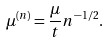Convert formula to latex. <formula><loc_0><loc_0><loc_500><loc_500>\mu ^ { ( n ) } = \frac { \mu } { t } n ^ { - 1 / 2 } .</formula> 